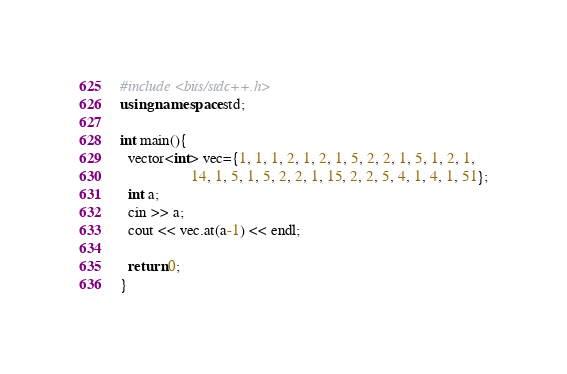<code> <loc_0><loc_0><loc_500><loc_500><_C++_>#include <bits/stdc++.h>
using namespace std;

int main(){
  vector<int> vec={1, 1, 1, 2, 1, 2, 1, 5, 2, 2, 1, 5, 1, 2, 1, 
                   14, 1, 5, 1, 5, 2, 2, 1, 15, 2, 2, 5, 4, 1, 4, 1, 51};
  int a;
  cin >> a;
  cout << vec.at(a-1) << endl;
  
  return 0;
}
</code> 